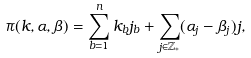Convert formula to latex. <formula><loc_0><loc_0><loc_500><loc_500>\pi ( k , \alpha , \beta ) = \sum _ { b = 1 } ^ { n } k _ { b } j _ { b } + \sum _ { j \in \mathbb { Z } _ { * } } ( \alpha _ { j } - \beta _ { j } ) j ,</formula> 